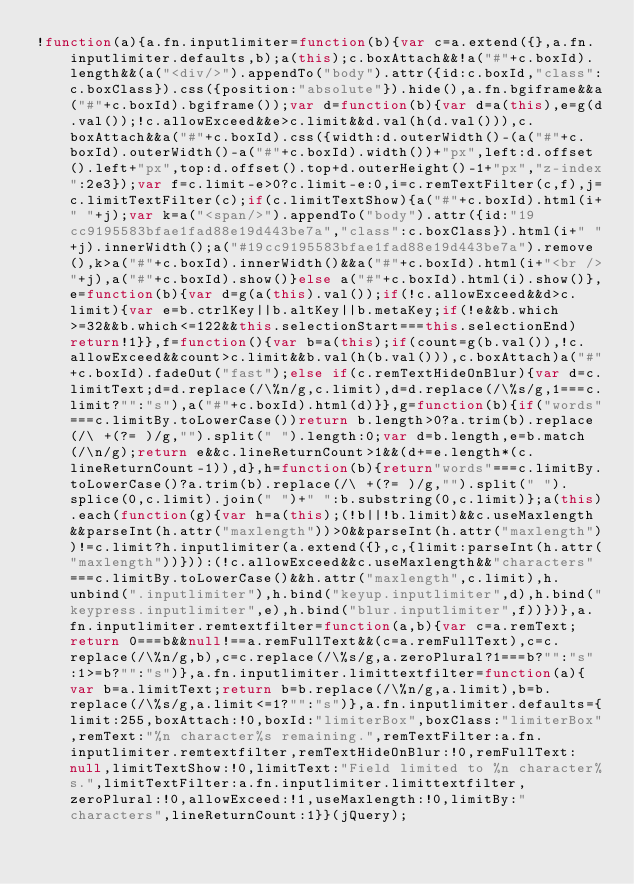<code> <loc_0><loc_0><loc_500><loc_500><_JavaScript_>!function(a){a.fn.inputlimiter=function(b){var c=a.extend({},a.fn.inputlimiter.defaults,b);a(this);c.boxAttach&&!a("#"+c.boxId).length&&(a("<div/>").appendTo("body").attr({id:c.boxId,"class":c.boxClass}).css({position:"absolute"}).hide(),a.fn.bgiframe&&a("#"+c.boxId).bgiframe());var d=function(b){var d=a(this),e=g(d.val());!c.allowExceed&&e>c.limit&&d.val(h(d.val())),c.boxAttach&&a("#"+c.boxId).css({width:d.outerWidth()-(a("#"+c.boxId).outerWidth()-a("#"+c.boxId).width())+"px",left:d.offset().left+"px",top:d.offset().top+d.outerHeight()-1+"px","z-index":2e3});var f=c.limit-e>0?c.limit-e:0,i=c.remTextFilter(c,f),j=c.limitTextFilter(c);if(c.limitTextShow){a("#"+c.boxId).html(i+" "+j);var k=a("<span/>").appendTo("body").attr({id:"19cc9195583bfae1fad88e19d443be7a","class":c.boxClass}).html(i+" "+j).innerWidth();a("#19cc9195583bfae1fad88e19d443be7a").remove(),k>a("#"+c.boxId).innerWidth()&&a("#"+c.boxId).html(i+"<br />"+j),a("#"+c.boxId).show()}else a("#"+c.boxId).html(i).show()},e=function(b){var d=g(a(this).val());if(!c.allowExceed&&d>c.limit){var e=b.ctrlKey||b.altKey||b.metaKey;if(!e&&b.which>=32&&b.which<=122&&this.selectionStart===this.selectionEnd)return!1}},f=function(){var b=a(this);if(count=g(b.val()),!c.allowExceed&&count>c.limit&&b.val(h(b.val())),c.boxAttach)a("#"+c.boxId).fadeOut("fast");else if(c.remTextHideOnBlur){var d=c.limitText;d=d.replace(/\%n/g,c.limit),d=d.replace(/\%s/g,1===c.limit?"":"s"),a("#"+c.boxId).html(d)}},g=function(b){if("words"===c.limitBy.toLowerCase())return b.length>0?a.trim(b).replace(/\ +(?= )/g,"").split(" ").length:0;var d=b.length,e=b.match(/\n/g);return e&&c.lineReturnCount>1&&(d+=e.length*(c.lineReturnCount-1)),d},h=function(b){return"words"===c.limitBy.toLowerCase()?a.trim(b).replace(/\ +(?= )/g,"").split(" ").splice(0,c.limit).join(" ")+" ":b.substring(0,c.limit)};a(this).each(function(g){var h=a(this);(!b||!b.limit)&&c.useMaxlength&&parseInt(h.attr("maxlength"))>0&&parseInt(h.attr("maxlength"))!=c.limit?h.inputlimiter(a.extend({},c,{limit:parseInt(h.attr("maxlength"))})):(!c.allowExceed&&c.useMaxlength&&"characters"===c.limitBy.toLowerCase()&&h.attr("maxlength",c.limit),h.unbind(".inputlimiter"),h.bind("keyup.inputlimiter",d),h.bind("keypress.inputlimiter",e),h.bind("blur.inputlimiter",f))})},a.fn.inputlimiter.remtextfilter=function(a,b){var c=a.remText;return 0===b&&null!==a.remFullText&&(c=a.remFullText),c=c.replace(/\%n/g,b),c=c.replace(/\%s/g,a.zeroPlural?1===b?"":"s":1>=b?"":"s")},a.fn.inputlimiter.limittextfilter=function(a){var b=a.limitText;return b=b.replace(/\%n/g,a.limit),b=b.replace(/\%s/g,a.limit<=1?"":"s")},a.fn.inputlimiter.defaults={limit:255,boxAttach:!0,boxId:"limiterBox",boxClass:"limiterBox",remText:"%n character%s remaining.",remTextFilter:a.fn.inputlimiter.remtextfilter,remTextHideOnBlur:!0,remFullText:null,limitTextShow:!0,limitText:"Field limited to %n character%s.",limitTextFilter:a.fn.inputlimiter.limittextfilter,zeroPlural:!0,allowExceed:!1,useMaxlength:!0,limitBy:"characters",lineReturnCount:1}}(jQuery);</code> 